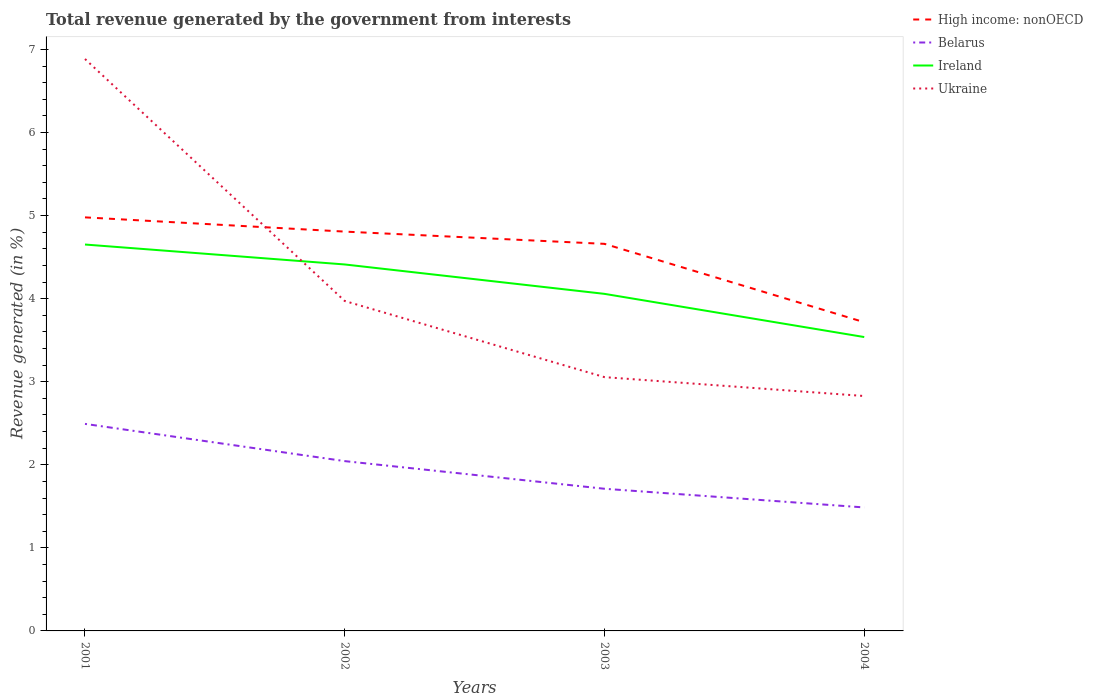Across all years, what is the maximum total revenue generated in Ireland?
Keep it short and to the point. 3.54. In which year was the total revenue generated in High income: nonOECD maximum?
Give a very brief answer. 2004. What is the total total revenue generated in Ukraine in the graph?
Give a very brief answer. 2.91. What is the difference between the highest and the second highest total revenue generated in Ireland?
Ensure brevity in your answer.  1.11. What is the difference between the highest and the lowest total revenue generated in Ukraine?
Provide a short and direct response. 1. Is the total revenue generated in Belarus strictly greater than the total revenue generated in Ireland over the years?
Make the answer very short. Yes. How many lines are there?
Offer a terse response. 4. How many years are there in the graph?
Your answer should be compact. 4. What is the difference between two consecutive major ticks on the Y-axis?
Provide a short and direct response. 1. Are the values on the major ticks of Y-axis written in scientific E-notation?
Your answer should be very brief. No. Does the graph contain grids?
Offer a terse response. No. Where does the legend appear in the graph?
Your answer should be very brief. Top right. How many legend labels are there?
Give a very brief answer. 4. What is the title of the graph?
Your response must be concise. Total revenue generated by the government from interests. Does "Kiribati" appear as one of the legend labels in the graph?
Make the answer very short. No. What is the label or title of the Y-axis?
Make the answer very short. Revenue generated (in %). What is the Revenue generated (in %) in High income: nonOECD in 2001?
Make the answer very short. 4.98. What is the Revenue generated (in %) in Belarus in 2001?
Give a very brief answer. 2.49. What is the Revenue generated (in %) of Ireland in 2001?
Keep it short and to the point. 4.65. What is the Revenue generated (in %) of Ukraine in 2001?
Keep it short and to the point. 6.88. What is the Revenue generated (in %) in High income: nonOECD in 2002?
Provide a succinct answer. 4.81. What is the Revenue generated (in %) in Belarus in 2002?
Give a very brief answer. 2.04. What is the Revenue generated (in %) in Ireland in 2002?
Keep it short and to the point. 4.41. What is the Revenue generated (in %) of Ukraine in 2002?
Give a very brief answer. 3.97. What is the Revenue generated (in %) of High income: nonOECD in 2003?
Your answer should be compact. 4.66. What is the Revenue generated (in %) of Belarus in 2003?
Your answer should be very brief. 1.71. What is the Revenue generated (in %) in Ireland in 2003?
Provide a short and direct response. 4.06. What is the Revenue generated (in %) of Ukraine in 2003?
Provide a succinct answer. 3.05. What is the Revenue generated (in %) in High income: nonOECD in 2004?
Make the answer very short. 3.72. What is the Revenue generated (in %) of Belarus in 2004?
Your answer should be very brief. 1.49. What is the Revenue generated (in %) of Ireland in 2004?
Provide a succinct answer. 3.54. What is the Revenue generated (in %) of Ukraine in 2004?
Offer a terse response. 2.83. Across all years, what is the maximum Revenue generated (in %) in High income: nonOECD?
Ensure brevity in your answer.  4.98. Across all years, what is the maximum Revenue generated (in %) in Belarus?
Make the answer very short. 2.49. Across all years, what is the maximum Revenue generated (in %) in Ireland?
Provide a succinct answer. 4.65. Across all years, what is the maximum Revenue generated (in %) in Ukraine?
Keep it short and to the point. 6.88. Across all years, what is the minimum Revenue generated (in %) in High income: nonOECD?
Your answer should be compact. 3.72. Across all years, what is the minimum Revenue generated (in %) in Belarus?
Give a very brief answer. 1.49. Across all years, what is the minimum Revenue generated (in %) in Ireland?
Offer a very short reply. 3.54. Across all years, what is the minimum Revenue generated (in %) in Ukraine?
Provide a succinct answer. 2.83. What is the total Revenue generated (in %) in High income: nonOECD in the graph?
Your response must be concise. 18.16. What is the total Revenue generated (in %) in Belarus in the graph?
Ensure brevity in your answer.  7.73. What is the total Revenue generated (in %) of Ireland in the graph?
Ensure brevity in your answer.  16.66. What is the total Revenue generated (in %) in Ukraine in the graph?
Ensure brevity in your answer.  16.74. What is the difference between the Revenue generated (in %) of High income: nonOECD in 2001 and that in 2002?
Offer a terse response. 0.17. What is the difference between the Revenue generated (in %) of Belarus in 2001 and that in 2002?
Your answer should be compact. 0.45. What is the difference between the Revenue generated (in %) in Ireland in 2001 and that in 2002?
Make the answer very short. 0.24. What is the difference between the Revenue generated (in %) in Ukraine in 2001 and that in 2002?
Your answer should be compact. 2.91. What is the difference between the Revenue generated (in %) in High income: nonOECD in 2001 and that in 2003?
Provide a short and direct response. 0.32. What is the difference between the Revenue generated (in %) in Belarus in 2001 and that in 2003?
Make the answer very short. 0.78. What is the difference between the Revenue generated (in %) in Ireland in 2001 and that in 2003?
Provide a short and direct response. 0.59. What is the difference between the Revenue generated (in %) in Ukraine in 2001 and that in 2003?
Your answer should be very brief. 3.83. What is the difference between the Revenue generated (in %) in High income: nonOECD in 2001 and that in 2004?
Offer a very short reply. 1.26. What is the difference between the Revenue generated (in %) of Belarus in 2001 and that in 2004?
Ensure brevity in your answer.  1.01. What is the difference between the Revenue generated (in %) of Ireland in 2001 and that in 2004?
Make the answer very short. 1.11. What is the difference between the Revenue generated (in %) of Ukraine in 2001 and that in 2004?
Keep it short and to the point. 4.06. What is the difference between the Revenue generated (in %) in High income: nonOECD in 2002 and that in 2003?
Your answer should be compact. 0.15. What is the difference between the Revenue generated (in %) in Belarus in 2002 and that in 2003?
Give a very brief answer. 0.33. What is the difference between the Revenue generated (in %) of Ireland in 2002 and that in 2003?
Your answer should be very brief. 0.35. What is the difference between the Revenue generated (in %) of Ukraine in 2002 and that in 2003?
Ensure brevity in your answer.  0.92. What is the difference between the Revenue generated (in %) of High income: nonOECD in 2002 and that in 2004?
Offer a very short reply. 1.09. What is the difference between the Revenue generated (in %) of Belarus in 2002 and that in 2004?
Your answer should be very brief. 0.56. What is the difference between the Revenue generated (in %) of Ireland in 2002 and that in 2004?
Keep it short and to the point. 0.87. What is the difference between the Revenue generated (in %) of Ukraine in 2002 and that in 2004?
Provide a short and direct response. 1.14. What is the difference between the Revenue generated (in %) in High income: nonOECD in 2003 and that in 2004?
Make the answer very short. 0.94. What is the difference between the Revenue generated (in %) of Belarus in 2003 and that in 2004?
Give a very brief answer. 0.22. What is the difference between the Revenue generated (in %) in Ireland in 2003 and that in 2004?
Offer a terse response. 0.52. What is the difference between the Revenue generated (in %) in Ukraine in 2003 and that in 2004?
Ensure brevity in your answer.  0.23. What is the difference between the Revenue generated (in %) in High income: nonOECD in 2001 and the Revenue generated (in %) in Belarus in 2002?
Your response must be concise. 2.93. What is the difference between the Revenue generated (in %) in High income: nonOECD in 2001 and the Revenue generated (in %) in Ireland in 2002?
Your response must be concise. 0.57. What is the difference between the Revenue generated (in %) of High income: nonOECD in 2001 and the Revenue generated (in %) of Ukraine in 2002?
Provide a succinct answer. 1.01. What is the difference between the Revenue generated (in %) of Belarus in 2001 and the Revenue generated (in %) of Ireland in 2002?
Ensure brevity in your answer.  -1.92. What is the difference between the Revenue generated (in %) of Belarus in 2001 and the Revenue generated (in %) of Ukraine in 2002?
Offer a terse response. -1.48. What is the difference between the Revenue generated (in %) of Ireland in 2001 and the Revenue generated (in %) of Ukraine in 2002?
Your answer should be compact. 0.68. What is the difference between the Revenue generated (in %) in High income: nonOECD in 2001 and the Revenue generated (in %) in Belarus in 2003?
Keep it short and to the point. 3.27. What is the difference between the Revenue generated (in %) in High income: nonOECD in 2001 and the Revenue generated (in %) in Ireland in 2003?
Your response must be concise. 0.92. What is the difference between the Revenue generated (in %) in High income: nonOECD in 2001 and the Revenue generated (in %) in Ukraine in 2003?
Offer a very short reply. 1.92. What is the difference between the Revenue generated (in %) in Belarus in 2001 and the Revenue generated (in %) in Ireland in 2003?
Provide a short and direct response. -1.57. What is the difference between the Revenue generated (in %) in Belarus in 2001 and the Revenue generated (in %) in Ukraine in 2003?
Provide a succinct answer. -0.56. What is the difference between the Revenue generated (in %) in Ireland in 2001 and the Revenue generated (in %) in Ukraine in 2003?
Give a very brief answer. 1.6. What is the difference between the Revenue generated (in %) of High income: nonOECD in 2001 and the Revenue generated (in %) of Belarus in 2004?
Make the answer very short. 3.49. What is the difference between the Revenue generated (in %) in High income: nonOECD in 2001 and the Revenue generated (in %) in Ireland in 2004?
Your response must be concise. 1.44. What is the difference between the Revenue generated (in %) of High income: nonOECD in 2001 and the Revenue generated (in %) of Ukraine in 2004?
Your answer should be compact. 2.15. What is the difference between the Revenue generated (in %) of Belarus in 2001 and the Revenue generated (in %) of Ireland in 2004?
Your answer should be compact. -1.05. What is the difference between the Revenue generated (in %) of Belarus in 2001 and the Revenue generated (in %) of Ukraine in 2004?
Provide a succinct answer. -0.34. What is the difference between the Revenue generated (in %) in Ireland in 2001 and the Revenue generated (in %) in Ukraine in 2004?
Provide a succinct answer. 1.82. What is the difference between the Revenue generated (in %) of High income: nonOECD in 2002 and the Revenue generated (in %) of Belarus in 2003?
Ensure brevity in your answer.  3.1. What is the difference between the Revenue generated (in %) of High income: nonOECD in 2002 and the Revenue generated (in %) of Ireland in 2003?
Give a very brief answer. 0.75. What is the difference between the Revenue generated (in %) in High income: nonOECD in 2002 and the Revenue generated (in %) in Ukraine in 2003?
Offer a terse response. 1.75. What is the difference between the Revenue generated (in %) of Belarus in 2002 and the Revenue generated (in %) of Ireland in 2003?
Your response must be concise. -2.01. What is the difference between the Revenue generated (in %) of Belarus in 2002 and the Revenue generated (in %) of Ukraine in 2003?
Offer a very short reply. -1.01. What is the difference between the Revenue generated (in %) of Ireland in 2002 and the Revenue generated (in %) of Ukraine in 2003?
Ensure brevity in your answer.  1.36. What is the difference between the Revenue generated (in %) of High income: nonOECD in 2002 and the Revenue generated (in %) of Belarus in 2004?
Offer a very short reply. 3.32. What is the difference between the Revenue generated (in %) in High income: nonOECD in 2002 and the Revenue generated (in %) in Ireland in 2004?
Give a very brief answer. 1.27. What is the difference between the Revenue generated (in %) of High income: nonOECD in 2002 and the Revenue generated (in %) of Ukraine in 2004?
Provide a succinct answer. 1.98. What is the difference between the Revenue generated (in %) in Belarus in 2002 and the Revenue generated (in %) in Ireland in 2004?
Give a very brief answer. -1.49. What is the difference between the Revenue generated (in %) of Belarus in 2002 and the Revenue generated (in %) of Ukraine in 2004?
Keep it short and to the point. -0.78. What is the difference between the Revenue generated (in %) in Ireland in 2002 and the Revenue generated (in %) in Ukraine in 2004?
Ensure brevity in your answer.  1.58. What is the difference between the Revenue generated (in %) in High income: nonOECD in 2003 and the Revenue generated (in %) in Belarus in 2004?
Offer a very short reply. 3.17. What is the difference between the Revenue generated (in %) in High income: nonOECD in 2003 and the Revenue generated (in %) in Ireland in 2004?
Your answer should be compact. 1.12. What is the difference between the Revenue generated (in %) in High income: nonOECD in 2003 and the Revenue generated (in %) in Ukraine in 2004?
Offer a very short reply. 1.83. What is the difference between the Revenue generated (in %) in Belarus in 2003 and the Revenue generated (in %) in Ireland in 2004?
Ensure brevity in your answer.  -1.83. What is the difference between the Revenue generated (in %) in Belarus in 2003 and the Revenue generated (in %) in Ukraine in 2004?
Your answer should be very brief. -1.12. What is the difference between the Revenue generated (in %) in Ireland in 2003 and the Revenue generated (in %) in Ukraine in 2004?
Offer a terse response. 1.23. What is the average Revenue generated (in %) in High income: nonOECD per year?
Keep it short and to the point. 4.54. What is the average Revenue generated (in %) of Belarus per year?
Provide a succinct answer. 1.93. What is the average Revenue generated (in %) of Ireland per year?
Give a very brief answer. 4.16. What is the average Revenue generated (in %) of Ukraine per year?
Give a very brief answer. 4.18. In the year 2001, what is the difference between the Revenue generated (in %) in High income: nonOECD and Revenue generated (in %) in Belarus?
Your answer should be compact. 2.49. In the year 2001, what is the difference between the Revenue generated (in %) of High income: nonOECD and Revenue generated (in %) of Ireland?
Offer a very short reply. 0.33. In the year 2001, what is the difference between the Revenue generated (in %) in High income: nonOECD and Revenue generated (in %) in Ukraine?
Offer a very short reply. -1.91. In the year 2001, what is the difference between the Revenue generated (in %) of Belarus and Revenue generated (in %) of Ireland?
Your response must be concise. -2.16. In the year 2001, what is the difference between the Revenue generated (in %) in Belarus and Revenue generated (in %) in Ukraine?
Offer a terse response. -4.39. In the year 2001, what is the difference between the Revenue generated (in %) of Ireland and Revenue generated (in %) of Ukraine?
Your answer should be compact. -2.23. In the year 2002, what is the difference between the Revenue generated (in %) in High income: nonOECD and Revenue generated (in %) in Belarus?
Keep it short and to the point. 2.76. In the year 2002, what is the difference between the Revenue generated (in %) in High income: nonOECD and Revenue generated (in %) in Ireland?
Ensure brevity in your answer.  0.4. In the year 2002, what is the difference between the Revenue generated (in %) in High income: nonOECD and Revenue generated (in %) in Ukraine?
Ensure brevity in your answer.  0.84. In the year 2002, what is the difference between the Revenue generated (in %) of Belarus and Revenue generated (in %) of Ireland?
Provide a short and direct response. -2.37. In the year 2002, what is the difference between the Revenue generated (in %) of Belarus and Revenue generated (in %) of Ukraine?
Ensure brevity in your answer.  -1.93. In the year 2002, what is the difference between the Revenue generated (in %) of Ireland and Revenue generated (in %) of Ukraine?
Your answer should be compact. 0.44. In the year 2003, what is the difference between the Revenue generated (in %) in High income: nonOECD and Revenue generated (in %) in Belarus?
Your response must be concise. 2.95. In the year 2003, what is the difference between the Revenue generated (in %) of High income: nonOECD and Revenue generated (in %) of Ireland?
Your answer should be compact. 0.6. In the year 2003, what is the difference between the Revenue generated (in %) of High income: nonOECD and Revenue generated (in %) of Ukraine?
Your answer should be compact. 1.6. In the year 2003, what is the difference between the Revenue generated (in %) of Belarus and Revenue generated (in %) of Ireland?
Your response must be concise. -2.35. In the year 2003, what is the difference between the Revenue generated (in %) in Belarus and Revenue generated (in %) in Ukraine?
Provide a short and direct response. -1.34. In the year 2004, what is the difference between the Revenue generated (in %) in High income: nonOECD and Revenue generated (in %) in Belarus?
Provide a succinct answer. 2.23. In the year 2004, what is the difference between the Revenue generated (in %) of High income: nonOECD and Revenue generated (in %) of Ireland?
Your answer should be compact. 0.18. In the year 2004, what is the difference between the Revenue generated (in %) of High income: nonOECD and Revenue generated (in %) of Ukraine?
Provide a short and direct response. 0.89. In the year 2004, what is the difference between the Revenue generated (in %) in Belarus and Revenue generated (in %) in Ireland?
Ensure brevity in your answer.  -2.05. In the year 2004, what is the difference between the Revenue generated (in %) in Belarus and Revenue generated (in %) in Ukraine?
Give a very brief answer. -1.34. In the year 2004, what is the difference between the Revenue generated (in %) of Ireland and Revenue generated (in %) of Ukraine?
Your answer should be compact. 0.71. What is the ratio of the Revenue generated (in %) of High income: nonOECD in 2001 to that in 2002?
Ensure brevity in your answer.  1.04. What is the ratio of the Revenue generated (in %) of Belarus in 2001 to that in 2002?
Make the answer very short. 1.22. What is the ratio of the Revenue generated (in %) of Ireland in 2001 to that in 2002?
Make the answer very short. 1.05. What is the ratio of the Revenue generated (in %) in Ukraine in 2001 to that in 2002?
Your answer should be compact. 1.73. What is the ratio of the Revenue generated (in %) in High income: nonOECD in 2001 to that in 2003?
Offer a very short reply. 1.07. What is the ratio of the Revenue generated (in %) of Belarus in 2001 to that in 2003?
Ensure brevity in your answer.  1.46. What is the ratio of the Revenue generated (in %) in Ireland in 2001 to that in 2003?
Ensure brevity in your answer.  1.15. What is the ratio of the Revenue generated (in %) of Ukraine in 2001 to that in 2003?
Provide a succinct answer. 2.25. What is the ratio of the Revenue generated (in %) of High income: nonOECD in 2001 to that in 2004?
Offer a very short reply. 1.34. What is the ratio of the Revenue generated (in %) of Belarus in 2001 to that in 2004?
Your answer should be compact. 1.68. What is the ratio of the Revenue generated (in %) in Ireland in 2001 to that in 2004?
Your response must be concise. 1.31. What is the ratio of the Revenue generated (in %) in Ukraine in 2001 to that in 2004?
Offer a very short reply. 2.43. What is the ratio of the Revenue generated (in %) of High income: nonOECD in 2002 to that in 2003?
Offer a very short reply. 1.03. What is the ratio of the Revenue generated (in %) in Belarus in 2002 to that in 2003?
Provide a short and direct response. 1.19. What is the ratio of the Revenue generated (in %) in Ireland in 2002 to that in 2003?
Keep it short and to the point. 1.09. What is the ratio of the Revenue generated (in %) of Ukraine in 2002 to that in 2003?
Offer a terse response. 1.3. What is the ratio of the Revenue generated (in %) of High income: nonOECD in 2002 to that in 2004?
Your response must be concise. 1.29. What is the ratio of the Revenue generated (in %) in Belarus in 2002 to that in 2004?
Ensure brevity in your answer.  1.38. What is the ratio of the Revenue generated (in %) in Ireland in 2002 to that in 2004?
Ensure brevity in your answer.  1.25. What is the ratio of the Revenue generated (in %) in Ukraine in 2002 to that in 2004?
Keep it short and to the point. 1.4. What is the ratio of the Revenue generated (in %) of High income: nonOECD in 2003 to that in 2004?
Keep it short and to the point. 1.25. What is the ratio of the Revenue generated (in %) of Belarus in 2003 to that in 2004?
Provide a short and direct response. 1.15. What is the ratio of the Revenue generated (in %) of Ireland in 2003 to that in 2004?
Offer a very short reply. 1.15. What is the ratio of the Revenue generated (in %) of Ukraine in 2003 to that in 2004?
Keep it short and to the point. 1.08. What is the difference between the highest and the second highest Revenue generated (in %) of High income: nonOECD?
Provide a succinct answer. 0.17. What is the difference between the highest and the second highest Revenue generated (in %) of Belarus?
Offer a very short reply. 0.45. What is the difference between the highest and the second highest Revenue generated (in %) of Ireland?
Keep it short and to the point. 0.24. What is the difference between the highest and the second highest Revenue generated (in %) of Ukraine?
Your answer should be very brief. 2.91. What is the difference between the highest and the lowest Revenue generated (in %) of High income: nonOECD?
Give a very brief answer. 1.26. What is the difference between the highest and the lowest Revenue generated (in %) in Belarus?
Offer a terse response. 1.01. What is the difference between the highest and the lowest Revenue generated (in %) in Ireland?
Keep it short and to the point. 1.11. What is the difference between the highest and the lowest Revenue generated (in %) in Ukraine?
Your answer should be compact. 4.06. 